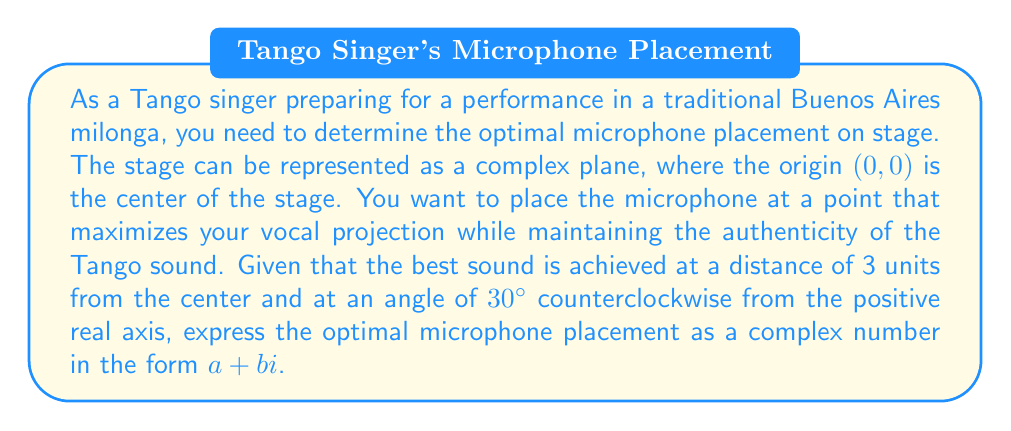Help me with this question. To solve this problem, we need to convert the given polar coordinates into a complex number in rectangular form. Let's break it down step by step:

1) We are given that the optimal point is 3 units away from the origin and at an angle of 30° counterclockwise from the positive real axis.

2) In polar form, this can be written as $(r, \theta) = (3, 30°)$.

3) To convert from polar form to rectangular form, we use the following formulas:
   $a = r \cos(\theta)$
   $b = r \sin(\theta)$

4) We need to convert 30° to radians:
   $30° = \frac{30 \pi}{180} = \frac{\pi}{6}$ radians

5) Now, let's calculate $a$:
   $a = 3 \cos(\frac{\pi}{6}) = 3 \cdot \frac{\sqrt{3}}{2} = \frac{3\sqrt{3}}{2}$

6) And calculate $b$:
   $b = 3 \sin(\frac{\pi}{6}) = 3 \cdot \frac{1}{2} = \frac{3}{2}$

7) Therefore, the complex number representing the optimal microphone placement is:
   $z = \frac{3\sqrt{3}}{2} + \frac{3}{2}i$

This complex number represents the point on the stage where you should place your microphone for the best Tango performance sound.
Answer: $z = \frac{3\sqrt{3}}{2} + \frac{3}{2}i$ 